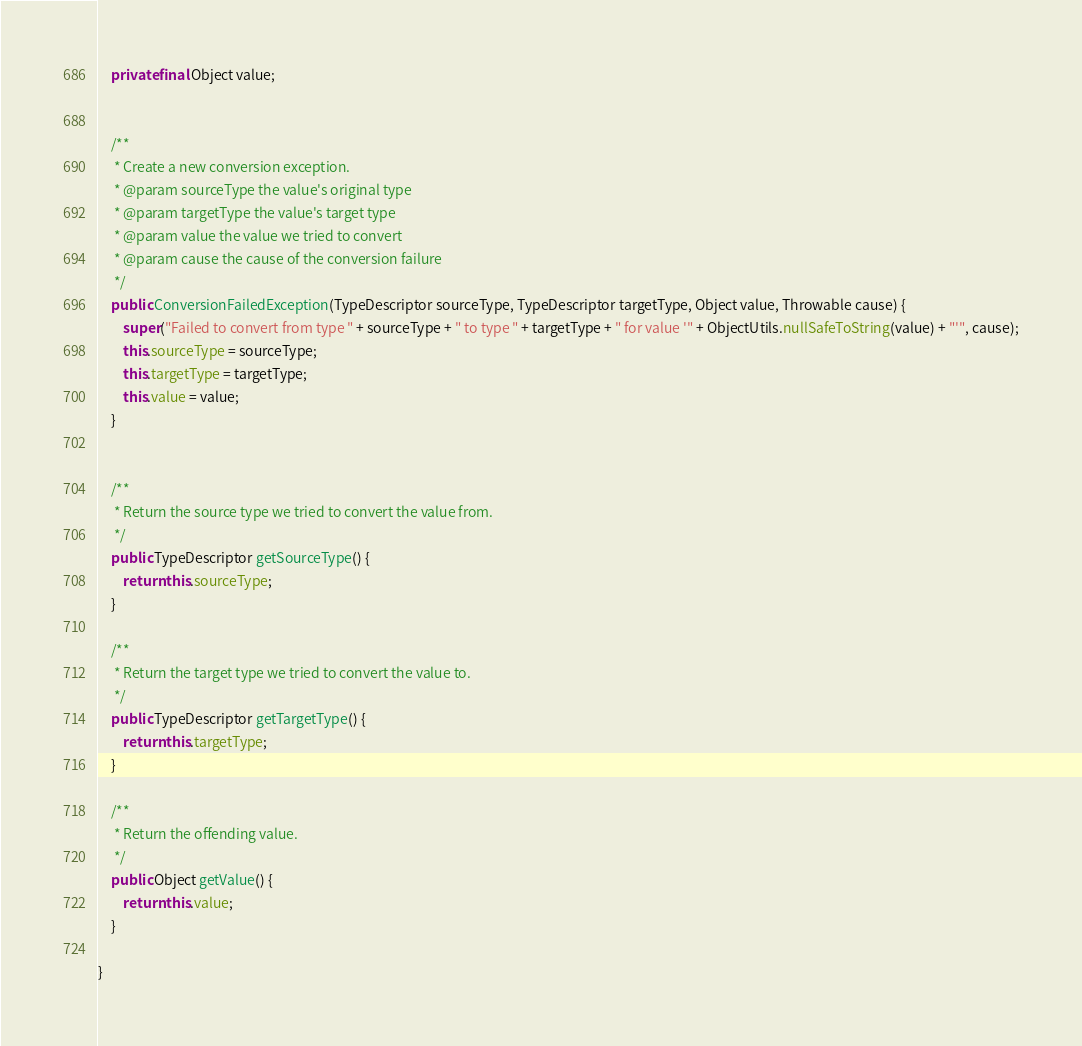<code> <loc_0><loc_0><loc_500><loc_500><_Java_>	private final Object value;


	/**
	 * Create a new conversion exception.
	 * @param sourceType the value's original type
	 * @param targetType the value's target type
	 * @param value the value we tried to convert
	 * @param cause the cause of the conversion failure
	 */
	public ConversionFailedException(TypeDescriptor sourceType, TypeDescriptor targetType, Object value, Throwable cause) {
		super("Failed to convert from type " + sourceType + " to type " + targetType + " for value '" + ObjectUtils.nullSafeToString(value) + "'", cause);
		this.sourceType = sourceType;
		this.targetType = targetType;
		this.value = value;
	}


	/**
	 * Return the source type we tried to convert the value from.
	 */
	public TypeDescriptor getSourceType() {
		return this.sourceType;
	}

	/**
	 * Return the target type we tried to convert the value to.
	 */
	public TypeDescriptor getTargetType() {
		return this.targetType;
	}

	/**
	 * Return the offending value.
	 */
	public Object getValue() {
		return this.value;
	}

}
</code> 